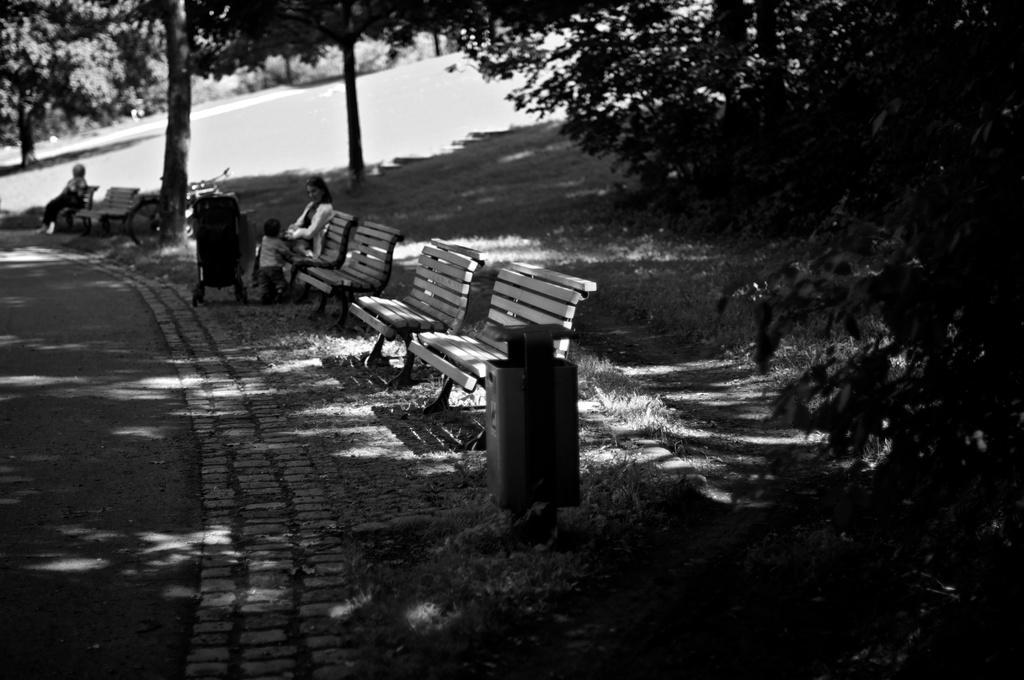Describe this image in one or two sentences. In the image we can see there are benches on the ground and there is dustbin kept on the ground. There are people sitting on the benches and there's grass on the ground. Behind there are trees and the image is in black and white colour. 